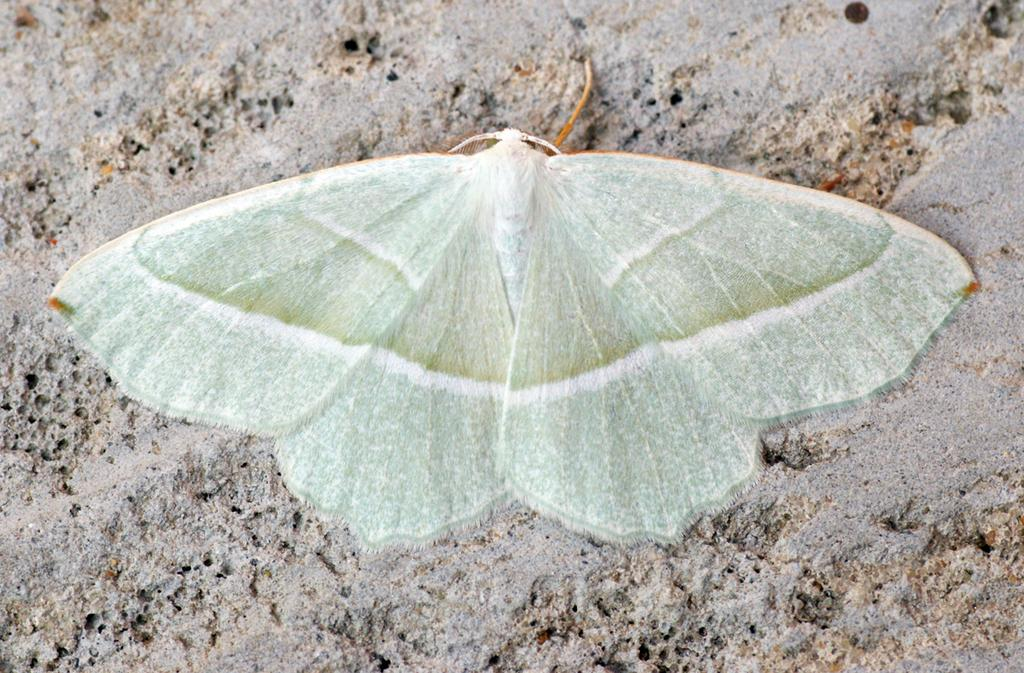What type of creature is in the image? There is a butterfly in the image. Where is the butterfly located? The butterfly is on the sand. What type of game is being played on the sand in the image? There is no game being played in the image; it only features a butterfly on the sand. What type of lettuce can be seen growing near the butterfly in the image? There is no lettuce present in the image; it only features a butterfly on the sand. 